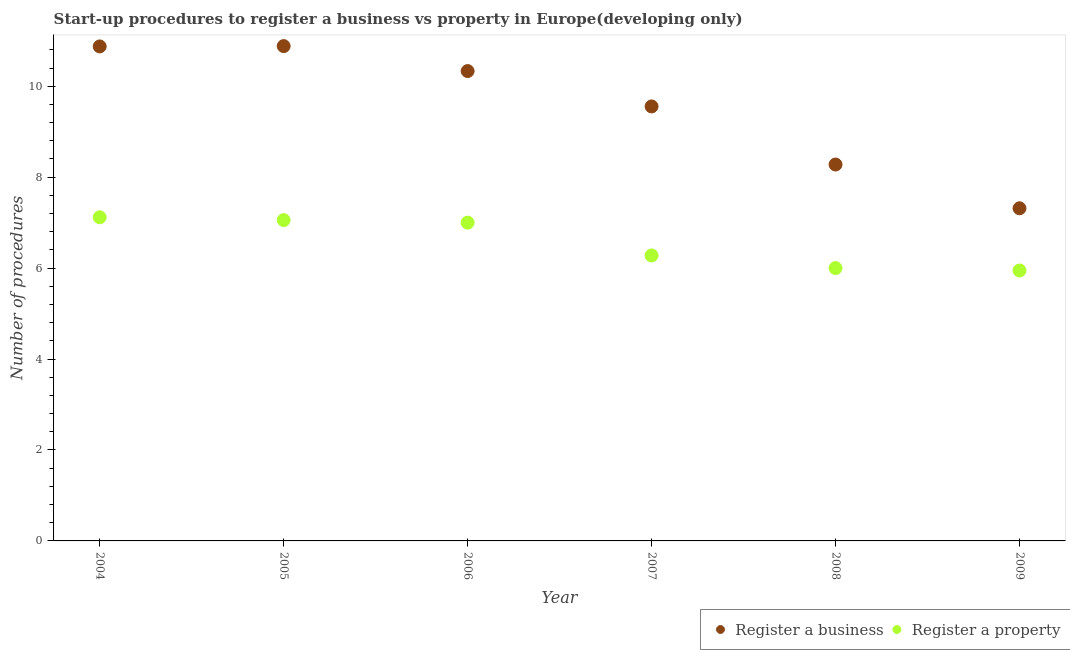What is the number of procedures to register a business in 2008?
Your response must be concise. 8.28. Across all years, what is the maximum number of procedures to register a property?
Your answer should be very brief. 7.12. Across all years, what is the minimum number of procedures to register a property?
Your answer should be compact. 5.95. In which year was the number of procedures to register a property maximum?
Give a very brief answer. 2004. What is the total number of procedures to register a property in the graph?
Make the answer very short. 39.4. What is the difference between the number of procedures to register a business in 2006 and that in 2009?
Your answer should be very brief. 3.02. What is the difference between the number of procedures to register a business in 2009 and the number of procedures to register a property in 2008?
Your answer should be compact. 1.32. What is the average number of procedures to register a property per year?
Ensure brevity in your answer.  6.57. In the year 2006, what is the difference between the number of procedures to register a business and number of procedures to register a property?
Keep it short and to the point. 3.33. In how many years, is the number of procedures to register a property greater than 3.2?
Your answer should be compact. 6. What is the ratio of the number of procedures to register a property in 2004 to that in 2007?
Keep it short and to the point. 1.13. Is the number of procedures to register a property in 2007 less than that in 2008?
Your answer should be compact. No. Is the difference between the number of procedures to register a property in 2006 and 2008 greater than the difference between the number of procedures to register a business in 2006 and 2008?
Keep it short and to the point. No. What is the difference between the highest and the second highest number of procedures to register a business?
Provide a succinct answer. 0.01. What is the difference between the highest and the lowest number of procedures to register a property?
Provide a short and direct response. 1.17. Does the number of procedures to register a business monotonically increase over the years?
Your answer should be compact. No. Is the number of procedures to register a business strictly less than the number of procedures to register a property over the years?
Your response must be concise. No. Does the graph contain any zero values?
Provide a succinct answer. No. Does the graph contain grids?
Your response must be concise. No. How many legend labels are there?
Give a very brief answer. 2. What is the title of the graph?
Provide a succinct answer. Start-up procedures to register a business vs property in Europe(developing only). What is the label or title of the X-axis?
Your response must be concise. Year. What is the label or title of the Y-axis?
Your answer should be compact. Number of procedures. What is the Number of procedures of Register a business in 2004?
Your response must be concise. 10.88. What is the Number of procedures of Register a property in 2004?
Your answer should be compact. 7.12. What is the Number of procedures in Register a business in 2005?
Keep it short and to the point. 10.88. What is the Number of procedures in Register a property in 2005?
Your answer should be very brief. 7.06. What is the Number of procedures of Register a business in 2006?
Your answer should be very brief. 10.33. What is the Number of procedures of Register a business in 2007?
Provide a short and direct response. 9.56. What is the Number of procedures of Register a property in 2007?
Your answer should be compact. 6.28. What is the Number of procedures in Register a business in 2008?
Your answer should be compact. 8.28. What is the Number of procedures in Register a property in 2008?
Provide a succinct answer. 6. What is the Number of procedures of Register a business in 2009?
Provide a succinct answer. 7.32. What is the Number of procedures in Register a property in 2009?
Offer a very short reply. 5.95. Across all years, what is the maximum Number of procedures in Register a business?
Offer a terse response. 10.88. Across all years, what is the maximum Number of procedures of Register a property?
Your answer should be compact. 7.12. Across all years, what is the minimum Number of procedures of Register a business?
Your response must be concise. 7.32. Across all years, what is the minimum Number of procedures in Register a property?
Offer a very short reply. 5.95. What is the total Number of procedures of Register a business in the graph?
Your answer should be compact. 57.24. What is the total Number of procedures of Register a property in the graph?
Your answer should be very brief. 39.4. What is the difference between the Number of procedures of Register a business in 2004 and that in 2005?
Keep it short and to the point. -0.01. What is the difference between the Number of procedures of Register a property in 2004 and that in 2005?
Provide a succinct answer. 0.06. What is the difference between the Number of procedures of Register a business in 2004 and that in 2006?
Your answer should be very brief. 0.54. What is the difference between the Number of procedures in Register a property in 2004 and that in 2006?
Provide a succinct answer. 0.12. What is the difference between the Number of procedures of Register a business in 2004 and that in 2007?
Offer a terse response. 1.32. What is the difference between the Number of procedures in Register a property in 2004 and that in 2007?
Give a very brief answer. 0.84. What is the difference between the Number of procedures of Register a business in 2004 and that in 2008?
Offer a very short reply. 2.6. What is the difference between the Number of procedures in Register a property in 2004 and that in 2008?
Offer a terse response. 1.12. What is the difference between the Number of procedures of Register a business in 2004 and that in 2009?
Your answer should be very brief. 3.56. What is the difference between the Number of procedures of Register a property in 2004 and that in 2009?
Offer a terse response. 1.17. What is the difference between the Number of procedures in Register a business in 2005 and that in 2006?
Keep it short and to the point. 0.55. What is the difference between the Number of procedures of Register a property in 2005 and that in 2006?
Offer a very short reply. 0.06. What is the difference between the Number of procedures in Register a business in 2005 and that in 2007?
Ensure brevity in your answer.  1.33. What is the difference between the Number of procedures of Register a business in 2005 and that in 2008?
Ensure brevity in your answer.  2.6. What is the difference between the Number of procedures in Register a property in 2005 and that in 2008?
Provide a short and direct response. 1.06. What is the difference between the Number of procedures of Register a business in 2005 and that in 2009?
Give a very brief answer. 3.57. What is the difference between the Number of procedures of Register a property in 2005 and that in 2009?
Offer a terse response. 1.11. What is the difference between the Number of procedures of Register a business in 2006 and that in 2007?
Keep it short and to the point. 0.78. What is the difference between the Number of procedures in Register a property in 2006 and that in 2007?
Keep it short and to the point. 0.72. What is the difference between the Number of procedures in Register a business in 2006 and that in 2008?
Offer a terse response. 2.06. What is the difference between the Number of procedures of Register a business in 2006 and that in 2009?
Provide a succinct answer. 3.02. What is the difference between the Number of procedures of Register a property in 2006 and that in 2009?
Give a very brief answer. 1.05. What is the difference between the Number of procedures of Register a business in 2007 and that in 2008?
Ensure brevity in your answer.  1.28. What is the difference between the Number of procedures in Register a property in 2007 and that in 2008?
Offer a terse response. 0.28. What is the difference between the Number of procedures in Register a business in 2007 and that in 2009?
Provide a short and direct response. 2.24. What is the difference between the Number of procedures in Register a property in 2007 and that in 2009?
Your answer should be compact. 0.33. What is the difference between the Number of procedures in Register a property in 2008 and that in 2009?
Ensure brevity in your answer.  0.05. What is the difference between the Number of procedures of Register a business in 2004 and the Number of procedures of Register a property in 2005?
Provide a short and direct response. 3.82. What is the difference between the Number of procedures of Register a business in 2004 and the Number of procedures of Register a property in 2006?
Ensure brevity in your answer.  3.88. What is the difference between the Number of procedures in Register a business in 2004 and the Number of procedures in Register a property in 2007?
Offer a very short reply. 4.6. What is the difference between the Number of procedures in Register a business in 2004 and the Number of procedures in Register a property in 2008?
Keep it short and to the point. 4.88. What is the difference between the Number of procedures of Register a business in 2004 and the Number of procedures of Register a property in 2009?
Offer a terse response. 4.93. What is the difference between the Number of procedures of Register a business in 2005 and the Number of procedures of Register a property in 2006?
Offer a very short reply. 3.88. What is the difference between the Number of procedures of Register a business in 2005 and the Number of procedures of Register a property in 2007?
Offer a very short reply. 4.6. What is the difference between the Number of procedures in Register a business in 2005 and the Number of procedures in Register a property in 2008?
Keep it short and to the point. 4.88. What is the difference between the Number of procedures in Register a business in 2005 and the Number of procedures in Register a property in 2009?
Provide a succinct answer. 4.93. What is the difference between the Number of procedures in Register a business in 2006 and the Number of procedures in Register a property in 2007?
Keep it short and to the point. 4.06. What is the difference between the Number of procedures of Register a business in 2006 and the Number of procedures of Register a property in 2008?
Offer a terse response. 4.33. What is the difference between the Number of procedures of Register a business in 2006 and the Number of procedures of Register a property in 2009?
Your response must be concise. 4.39. What is the difference between the Number of procedures in Register a business in 2007 and the Number of procedures in Register a property in 2008?
Ensure brevity in your answer.  3.56. What is the difference between the Number of procedures in Register a business in 2007 and the Number of procedures in Register a property in 2009?
Keep it short and to the point. 3.61. What is the difference between the Number of procedures in Register a business in 2008 and the Number of procedures in Register a property in 2009?
Your answer should be very brief. 2.33. What is the average Number of procedures of Register a business per year?
Your response must be concise. 9.54. What is the average Number of procedures in Register a property per year?
Provide a succinct answer. 6.57. In the year 2004, what is the difference between the Number of procedures of Register a business and Number of procedures of Register a property?
Offer a very short reply. 3.76. In the year 2005, what is the difference between the Number of procedures of Register a business and Number of procedures of Register a property?
Your response must be concise. 3.83. In the year 2006, what is the difference between the Number of procedures in Register a business and Number of procedures in Register a property?
Keep it short and to the point. 3.33. In the year 2007, what is the difference between the Number of procedures of Register a business and Number of procedures of Register a property?
Keep it short and to the point. 3.28. In the year 2008, what is the difference between the Number of procedures in Register a business and Number of procedures in Register a property?
Make the answer very short. 2.28. In the year 2009, what is the difference between the Number of procedures in Register a business and Number of procedures in Register a property?
Your answer should be very brief. 1.37. What is the ratio of the Number of procedures in Register a property in 2004 to that in 2005?
Keep it short and to the point. 1.01. What is the ratio of the Number of procedures of Register a business in 2004 to that in 2006?
Your answer should be compact. 1.05. What is the ratio of the Number of procedures of Register a property in 2004 to that in 2006?
Make the answer very short. 1.02. What is the ratio of the Number of procedures in Register a business in 2004 to that in 2007?
Your response must be concise. 1.14. What is the ratio of the Number of procedures of Register a property in 2004 to that in 2007?
Give a very brief answer. 1.13. What is the ratio of the Number of procedures in Register a business in 2004 to that in 2008?
Offer a very short reply. 1.31. What is the ratio of the Number of procedures of Register a property in 2004 to that in 2008?
Offer a very short reply. 1.19. What is the ratio of the Number of procedures of Register a business in 2004 to that in 2009?
Give a very brief answer. 1.49. What is the ratio of the Number of procedures in Register a property in 2004 to that in 2009?
Offer a terse response. 1.2. What is the ratio of the Number of procedures in Register a business in 2005 to that in 2006?
Provide a succinct answer. 1.05. What is the ratio of the Number of procedures in Register a property in 2005 to that in 2006?
Keep it short and to the point. 1.01. What is the ratio of the Number of procedures of Register a business in 2005 to that in 2007?
Make the answer very short. 1.14. What is the ratio of the Number of procedures of Register a property in 2005 to that in 2007?
Ensure brevity in your answer.  1.12. What is the ratio of the Number of procedures of Register a business in 2005 to that in 2008?
Your answer should be compact. 1.31. What is the ratio of the Number of procedures in Register a property in 2005 to that in 2008?
Provide a succinct answer. 1.18. What is the ratio of the Number of procedures of Register a business in 2005 to that in 2009?
Provide a succinct answer. 1.49. What is the ratio of the Number of procedures of Register a property in 2005 to that in 2009?
Make the answer very short. 1.19. What is the ratio of the Number of procedures of Register a business in 2006 to that in 2007?
Your answer should be compact. 1.08. What is the ratio of the Number of procedures in Register a property in 2006 to that in 2007?
Ensure brevity in your answer.  1.11. What is the ratio of the Number of procedures of Register a business in 2006 to that in 2008?
Offer a terse response. 1.25. What is the ratio of the Number of procedures of Register a business in 2006 to that in 2009?
Provide a short and direct response. 1.41. What is the ratio of the Number of procedures in Register a property in 2006 to that in 2009?
Your response must be concise. 1.18. What is the ratio of the Number of procedures in Register a business in 2007 to that in 2008?
Give a very brief answer. 1.15. What is the ratio of the Number of procedures in Register a property in 2007 to that in 2008?
Give a very brief answer. 1.05. What is the ratio of the Number of procedures of Register a business in 2007 to that in 2009?
Your response must be concise. 1.31. What is the ratio of the Number of procedures of Register a property in 2007 to that in 2009?
Offer a terse response. 1.06. What is the ratio of the Number of procedures in Register a business in 2008 to that in 2009?
Offer a very short reply. 1.13. What is the ratio of the Number of procedures in Register a property in 2008 to that in 2009?
Your response must be concise. 1.01. What is the difference between the highest and the second highest Number of procedures in Register a business?
Offer a very short reply. 0.01. What is the difference between the highest and the second highest Number of procedures of Register a property?
Your answer should be compact. 0.06. What is the difference between the highest and the lowest Number of procedures of Register a business?
Your response must be concise. 3.57. What is the difference between the highest and the lowest Number of procedures in Register a property?
Your response must be concise. 1.17. 